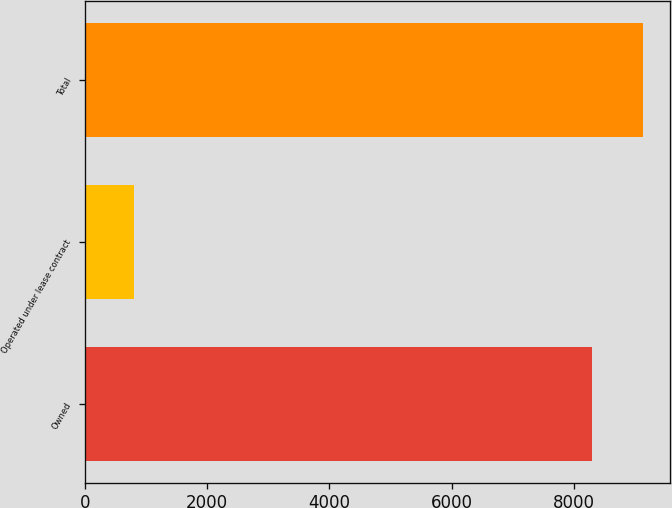<chart> <loc_0><loc_0><loc_500><loc_500><bar_chart><fcel>Owned<fcel>Operated under lease contract<fcel>Total<nl><fcel>8292<fcel>802<fcel>9121.2<nl></chart> 